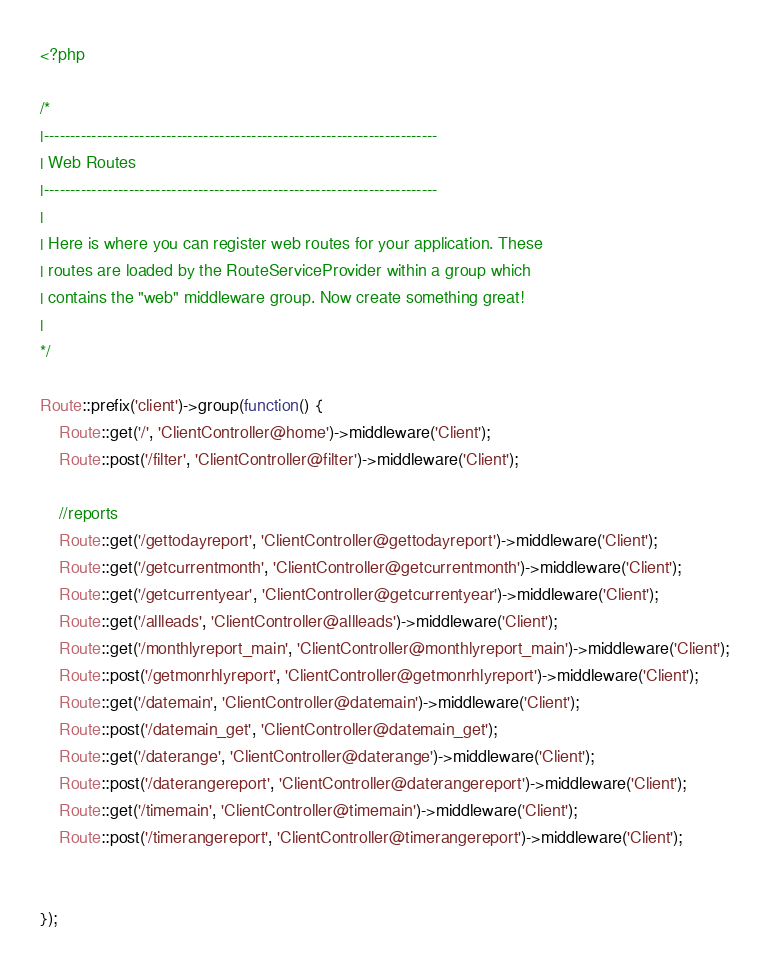<code> <loc_0><loc_0><loc_500><loc_500><_PHP_><?php

/*
|--------------------------------------------------------------------------
| Web Routes
|--------------------------------------------------------------------------
|
| Here is where you can register web routes for your application. These
| routes are loaded by the RouteServiceProvider within a group which
| contains the "web" middleware group. Now create something great!
|
*/

Route::prefix('client')->group(function() {
    Route::get('/', 'ClientController@home')->middleware('Client');
    Route::post('/filter', 'ClientController@filter')->middleware('Client');

    //reports
    Route::get('/gettodayreport', 'ClientController@gettodayreport')->middleware('Client');
    Route::get('/getcurrentmonth', 'ClientController@getcurrentmonth')->middleware('Client');
    Route::get('/getcurrentyear', 'ClientController@getcurrentyear')->middleware('Client');
    Route::get('/allleads', 'ClientController@allleads')->middleware('Client');
    Route::get('/monthlyreport_main', 'ClientController@monthlyreport_main')->middleware('Client');
    Route::post('/getmonrhlyreport', 'ClientController@getmonrhlyreport')->middleware('Client');
    Route::get('/datemain', 'ClientController@datemain')->middleware('Client');
    Route::post('/datemain_get', 'ClientController@datemain_get');
    Route::get('/daterange', 'ClientController@daterange')->middleware('Client');
    Route::post('/daterangereport', 'ClientController@daterangereport')->middleware('Client');
    Route::get('/timemain', 'ClientController@timemain')->middleware('Client');
    Route::post('/timerangereport', 'ClientController@timerangereport')->middleware('Client');
    
    
});
</code> 